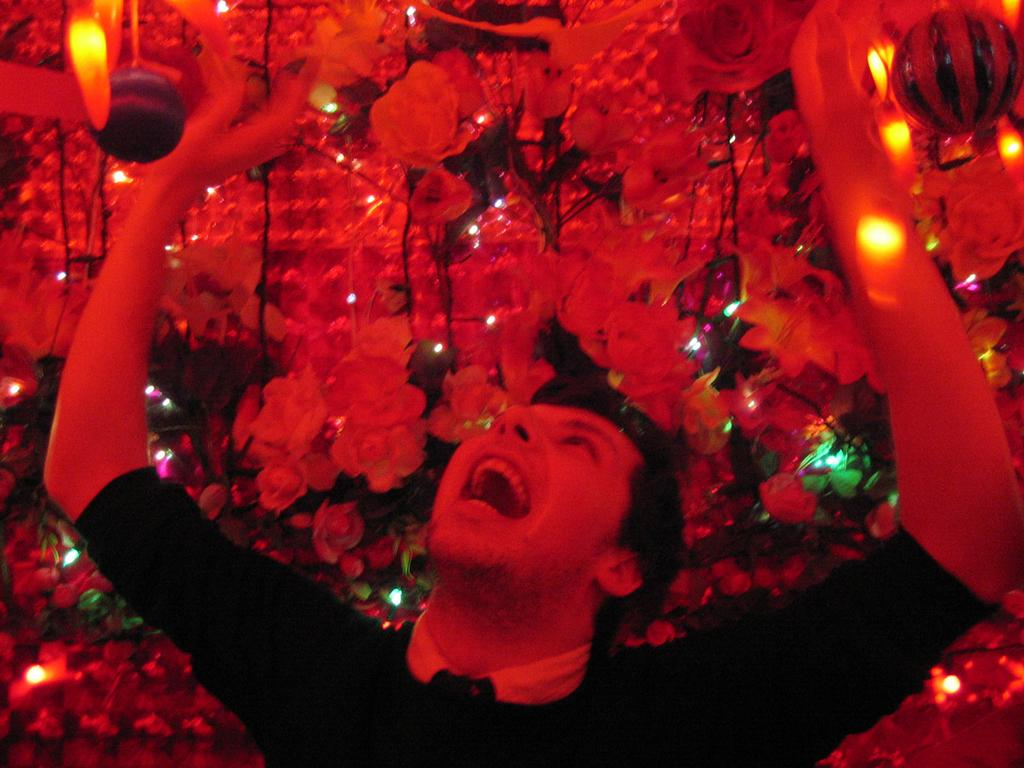Who or what is present in the image? There is a person in the image. What type of decorations can be seen in the image? There are many artificial flowers and artificial plants in the image. What else can be seen in the image besides the person and decorations? There are lights in the image. How many roots can be seen growing from the artificial plants in the image? There are no roots visible in the image, as the plants are artificial. 